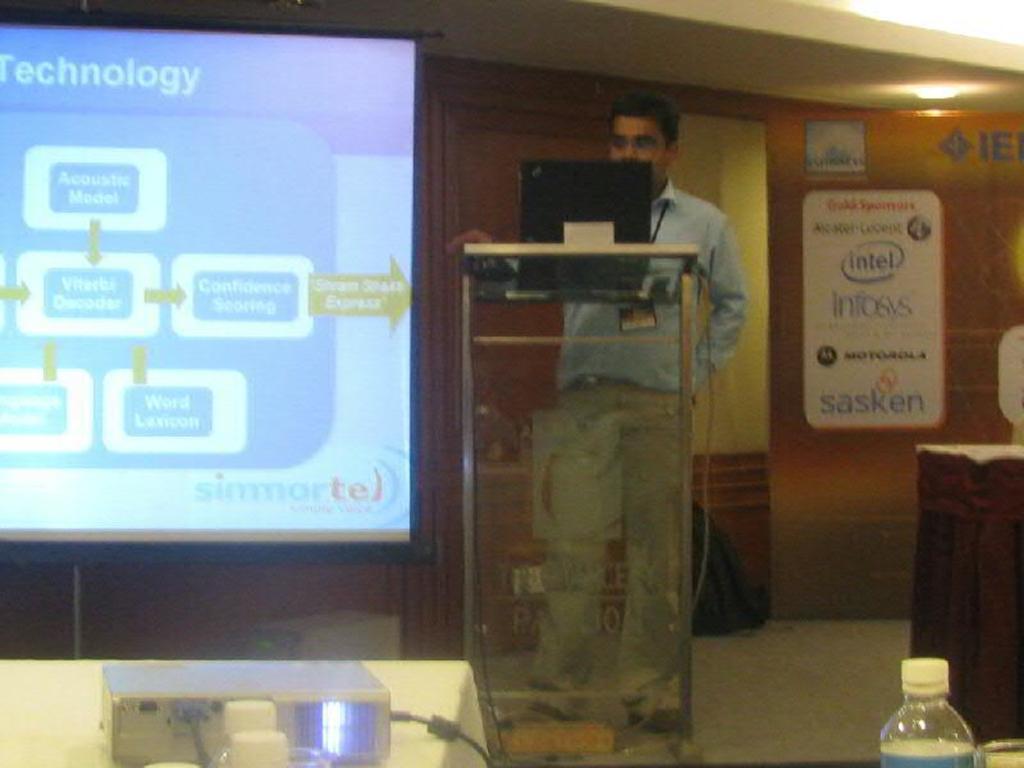What companies are depicted on the board behind the speaker?
Provide a succinct answer. Intel, infosys, motorola, sasken. 